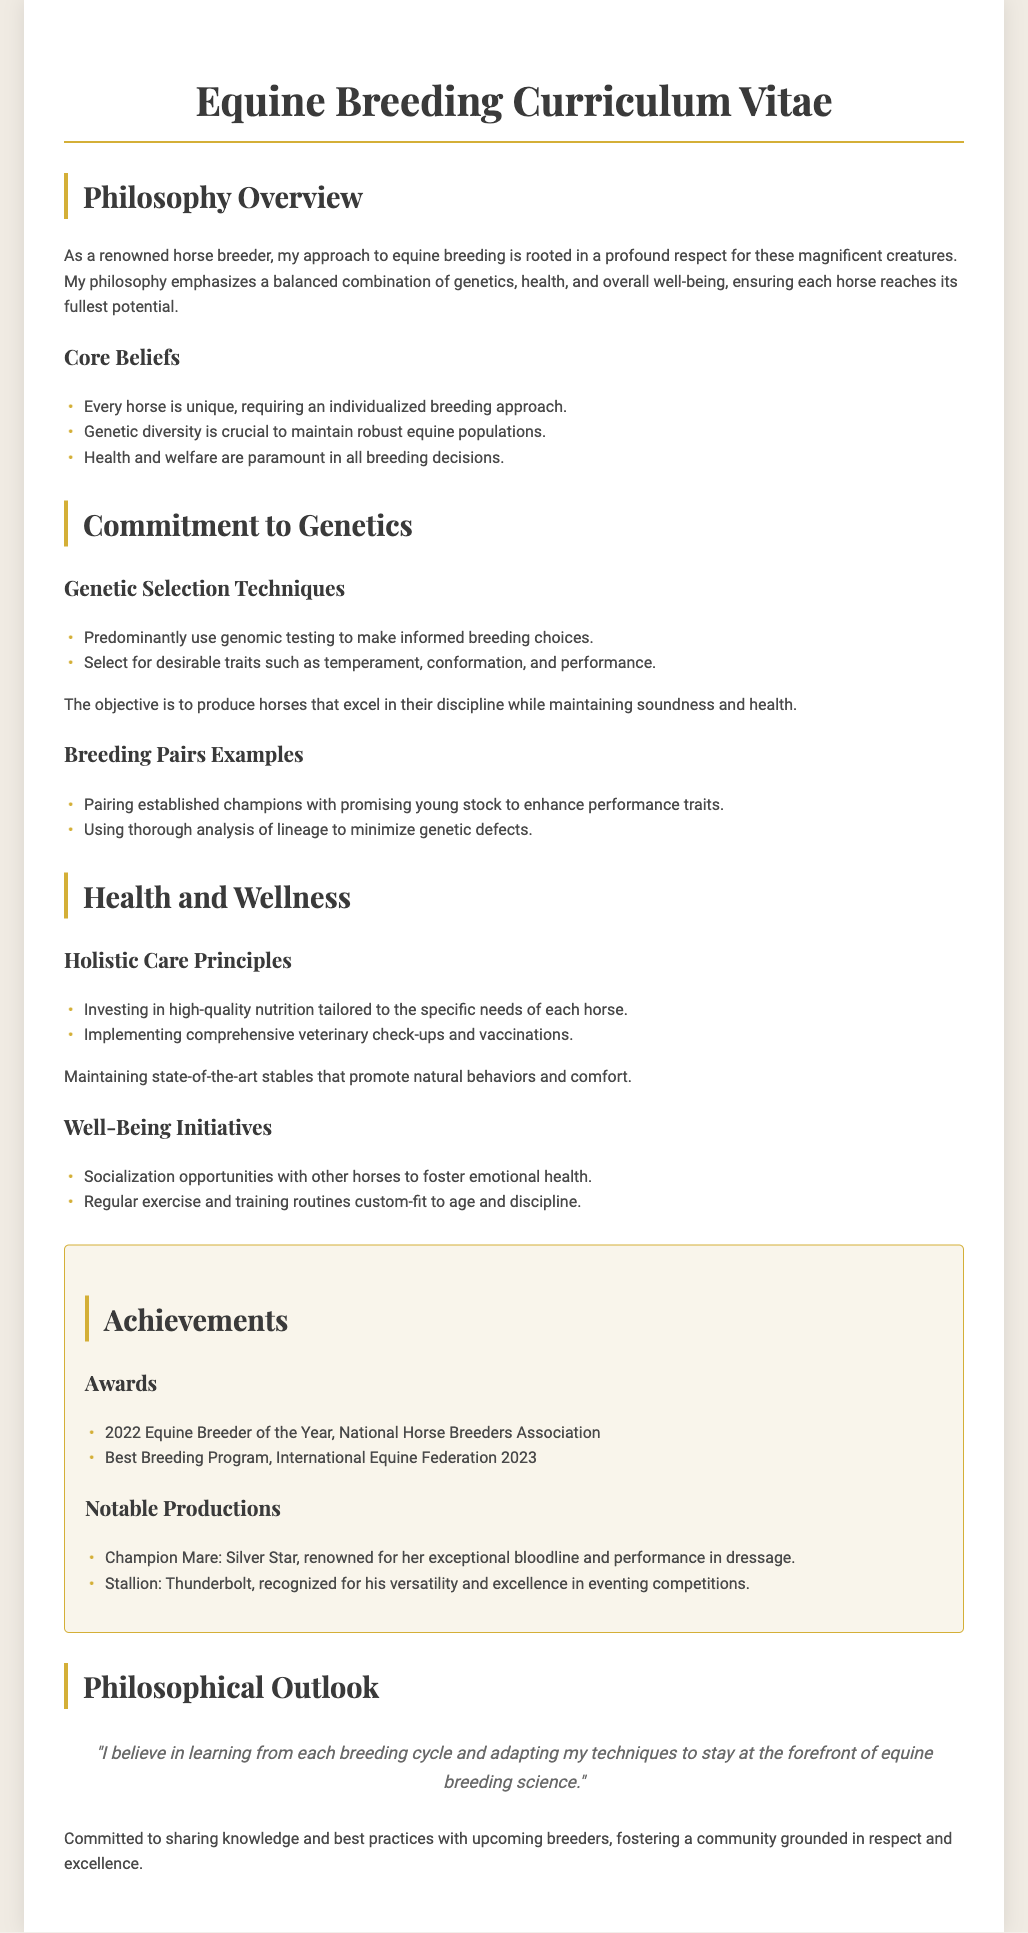What is the name of the document? The title of the document is included in the header.
Answer: Equine Breeding Curriculum Vitae What is emphasized in the breeding philosophy? The overview section summarizes the key aspects of the breeding philosophy.
Answer: Balance of genetics, health, and well-being Which award did the breeder receive in 2022? The Achievements section lists awards received and their corresponding years.
Answer: Equine Breeder of the Year What is a core belief regarding horses? The core beliefs are outlined in the document, highlighting key principles.
Answer: Every horse is unique What genetic selection technique is predominantly used? The section highlights techniques utilized in breeding decisions.
Answer: Genomic testing Name one notable production mentioned. The notable productions are listed in the Achievements section of the document.
Answer: Silver Star What type of care principles are implemented? The Health and Wellness section discusses care practices for the horses.
Answer: Holistic Care Principles What is identified as crucial for equine populations? The Core Beliefs section specifies critical factors in breeding practices.
Answer: Genetic diversity Which notable stallion is recognized for eventing? The notable productions list gives specific names of produced horses and their disciplines.
Answer: Thunderbolt 